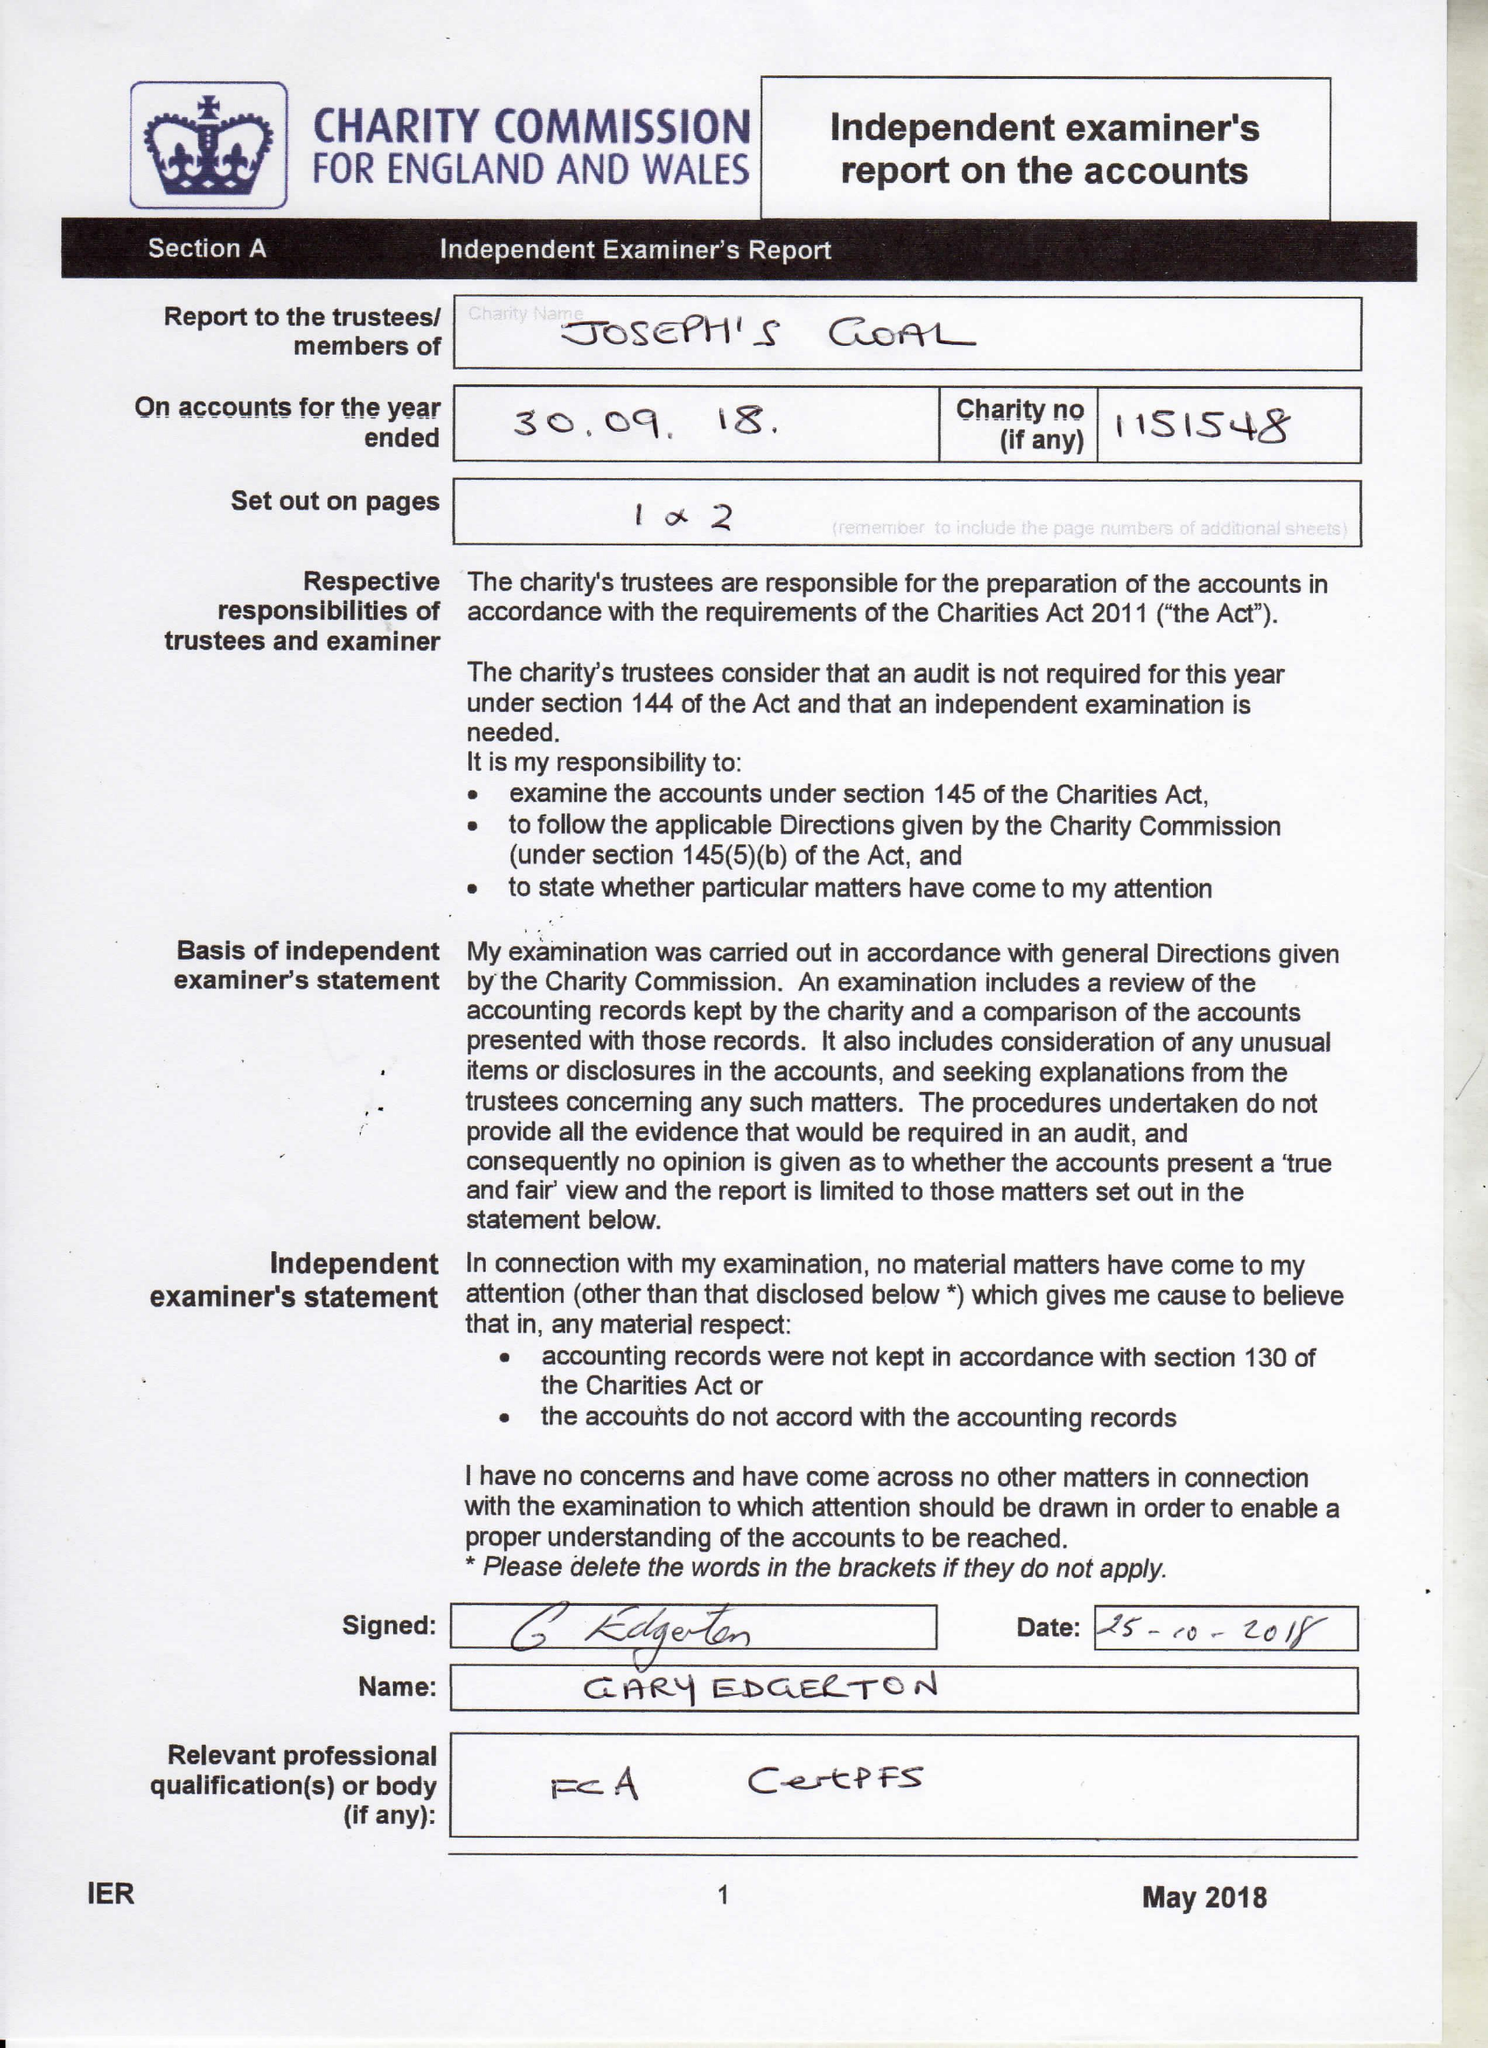What is the value for the spending_annually_in_british_pounds?
Answer the question using a single word or phrase. 197328.00 